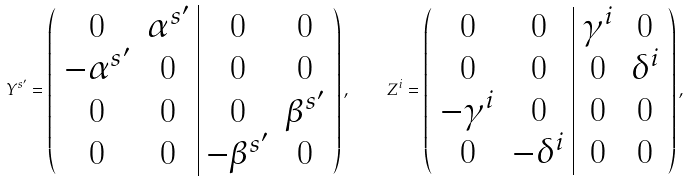Convert formula to latex. <formula><loc_0><loc_0><loc_500><loc_500>Y ^ { s ^ { \prime } } = \left ( \begin{array} { c c | c c } 0 & \alpha ^ { s ^ { \prime } } & 0 & 0 \\ - \alpha ^ { s ^ { \prime } } & 0 & 0 & 0 \\ 0 & 0 & 0 & \beta ^ { s ^ { \prime } } \\ 0 & 0 & - \beta ^ { s ^ { \prime } } & 0 \end{array} \right ) , \quad Z ^ { i } = \left ( \begin{array} { c c | c c } 0 & 0 & \gamma ^ { i } & 0 \\ 0 & 0 & 0 & \delta ^ { i } \\ - \gamma ^ { i } & 0 & 0 & 0 \\ 0 & - \delta ^ { i } & 0 & 0 \end{array} \right ) ,</formula> 